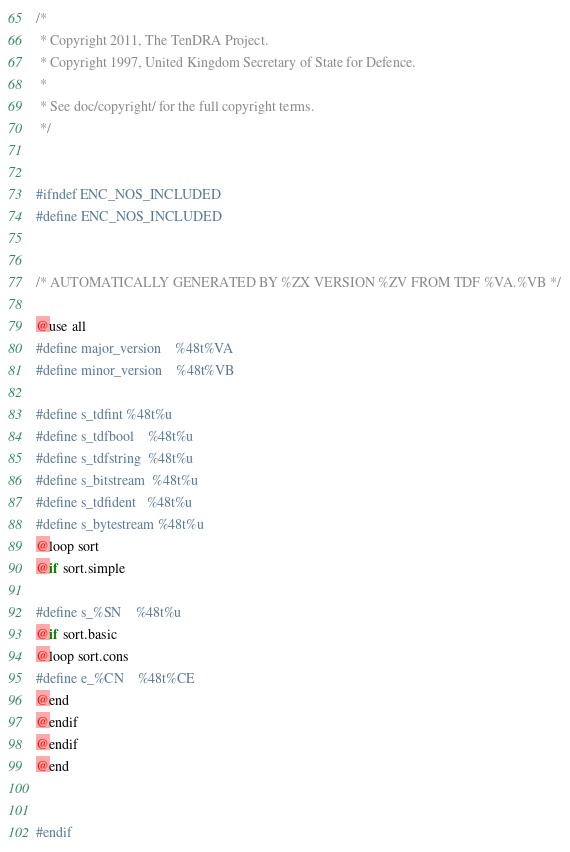<code> <loc_0><loc_0><loc_500><loc_500><_C_>/*
 * Copyright 2011, The TenDRA Project.
 * Copyright 1997, United Kingdom Secretary of State for Defence.
 *
 * See doc/copyright/ for the full copyright terms.
 */


#ifndef ENC_NOS_INCLUDED
#define ENC_NOS_INCLUDED


/* AUTOMATICALLY GENERATED BY %ZX VERSION %ZV FROM TDF %VA.%VB */

@use all
#define major_version	%48t%VA
#define minor_version	%48t%VB

#define s_tdfint	%48t%u
#define s_tdfbool	%48t%u
#define s_tdfstring	%48t%u
#define s_bitstream	%48t%u
#define s_tdfident	%48t%u
#define s_bytestream	%48t%u
@loop sort
@if sort.simple

#define s_%SN	%48t%u
@if sort.basic
@loop sort.cons
#define e_%CN	%48t%CE
@end
@endif
@endif
@end


#endif
</code> 